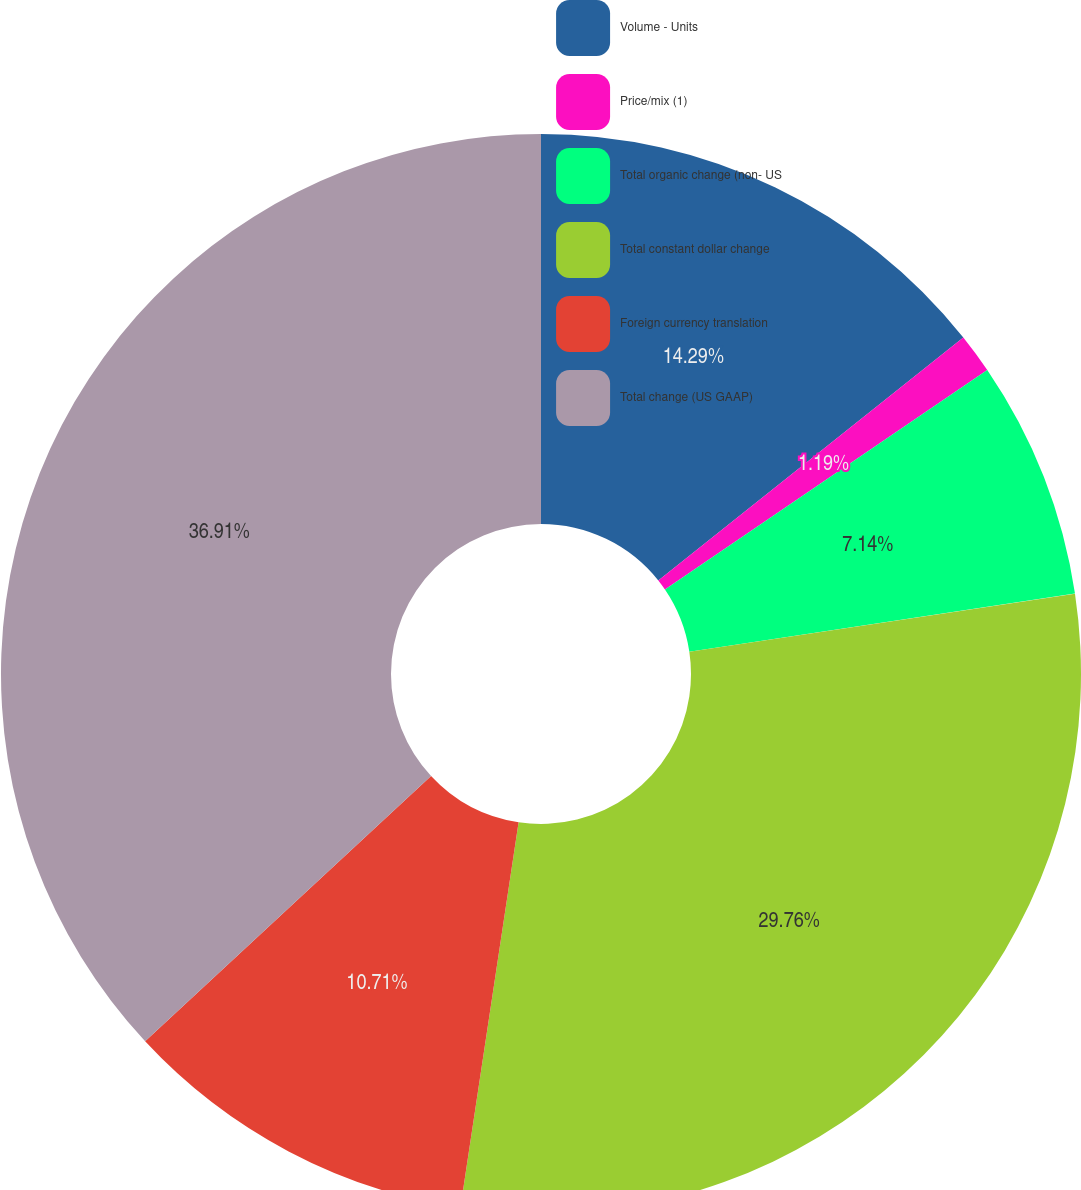Convert chart. <chart><loc_0><loc_0><loc_500><loc_500><pie_chart><fcel>Volume - Units<fcel>Price/mix (1)<fcel>Total organic change (non- US<fcel>Total constant dollar change<fcel>Foreign currency translation<fcel>Total change (US GAAP)<nl><fcel>14.29%<fcel>1.19%<fcel>7.14%<fcel>29.76%<fcel>10.71%<fcel>36.9%<nl></chart> 